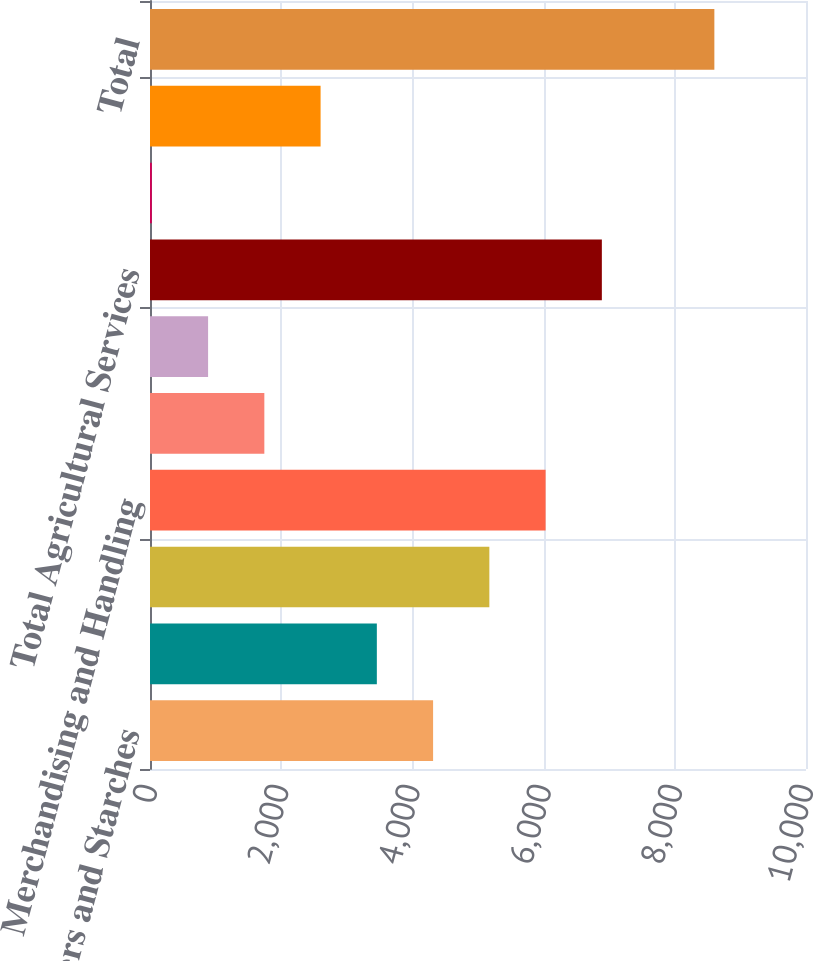Convert chart to OTSL. <chart><loc_0><loc_0><loc_500><loc_500><bar_chart><fcel>Sweeteners and Starches<fcel>Bioproducts<fcel>Total Corn Processing<fcel>Merchandising and Handling<fcel>Milling and Other<fcel>Transportation<fcel>Total Agricultural Services<fcel>Financial<fcel>Total Other<fcel>Total<nl><fcel>4315.5<fcel>3458<fcel>5173<fcel>6030.5<fcel>1743<fcel>885.5<fcel>6888<fcel>28<fcel>2600.5<fcel>8603<nl></chart> 